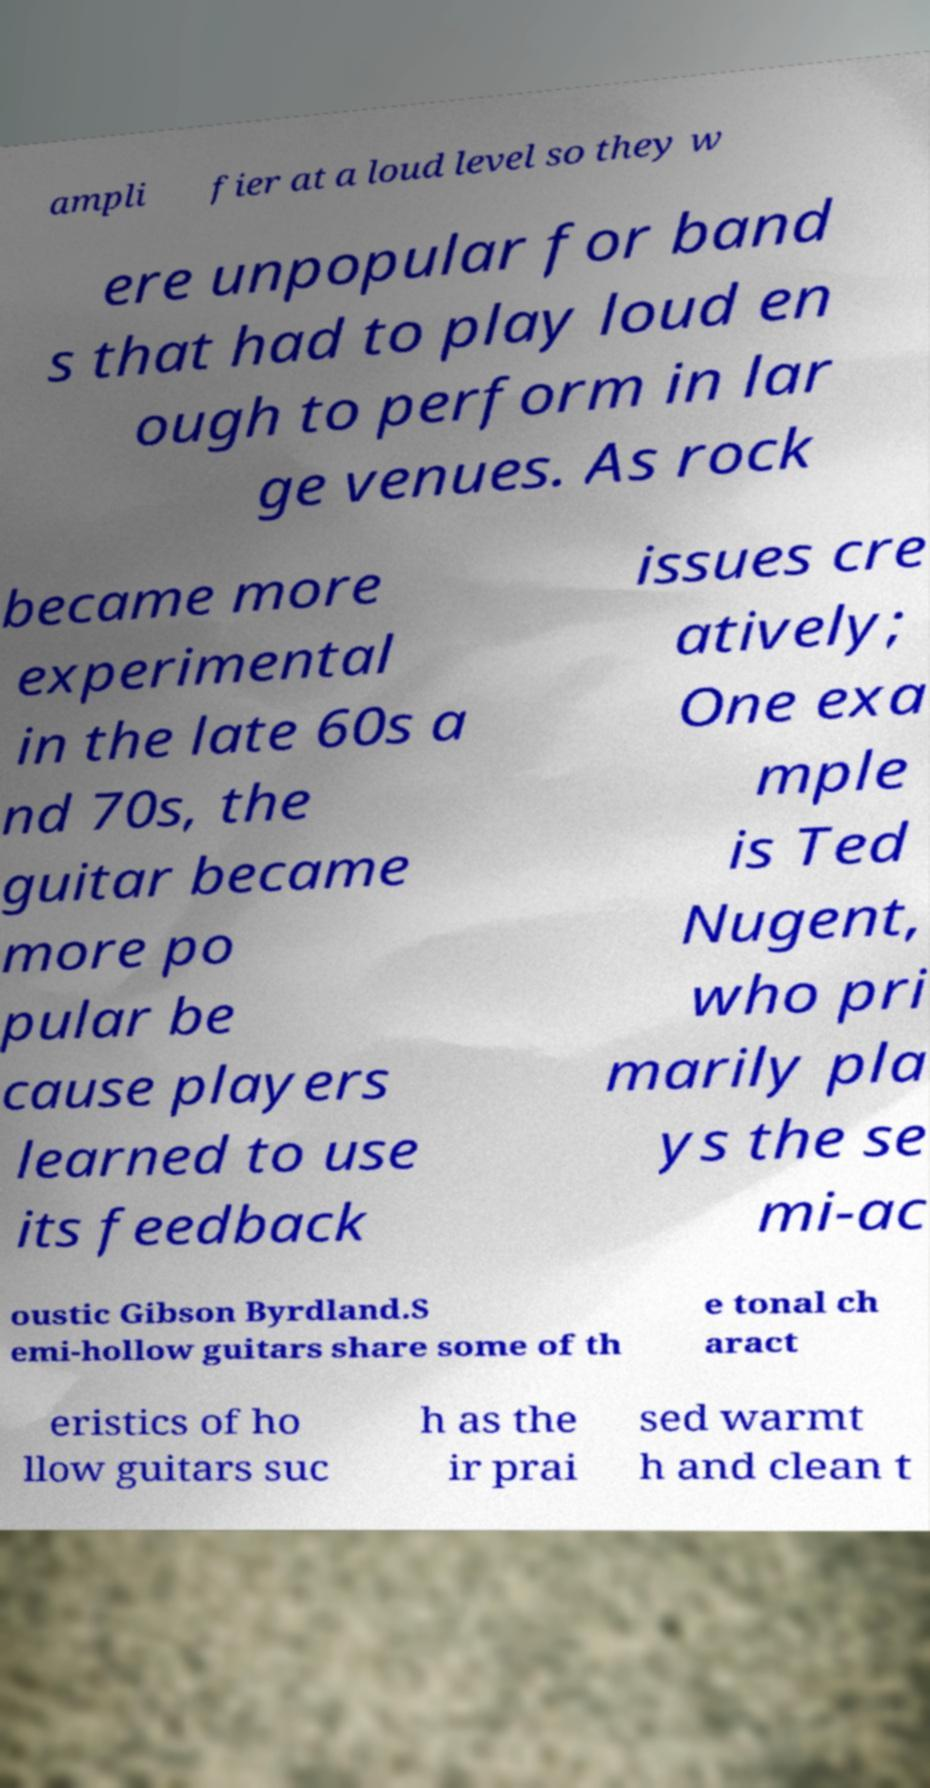Can you accurately transcribe the text from the provided image for me? ampli fier at a loud level so they w ere unpopular for band s that had to play loud en ough to perform in lar ge venues. As rock became more experimental in the late 60s a nd 70s, the guitar became more po pular be cause players learned to use its feedback issues cre atively; One exa mple is Ted Nugent, who pri marily pla ys the se mi-ac oustic Gibson Byrdland.S emi-hollow guitars share some of th e tonal ch aract eristics of ho llow guitars suc h as the ir prai sed warmt h and clean t 